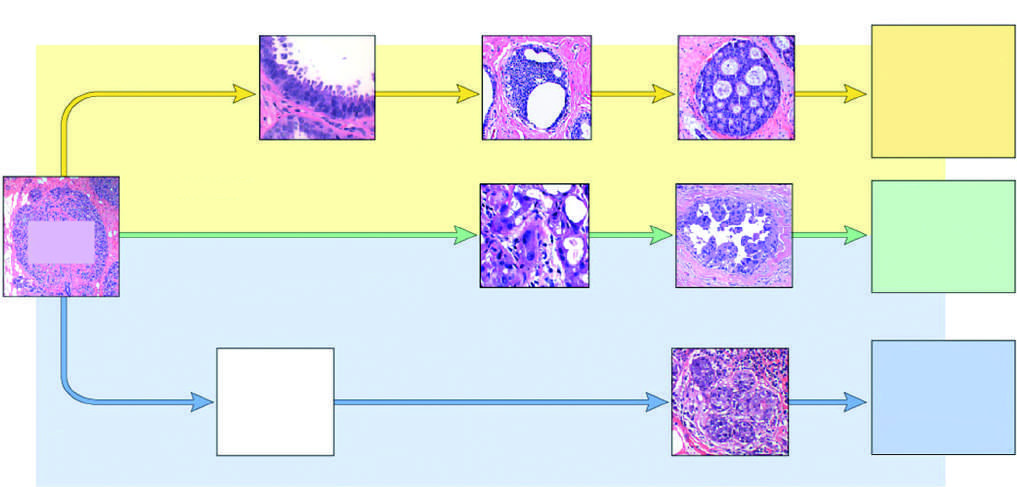what are the majority of triple-negative cancers classified as?
Answer the question using a single word or phrase. Basal-like 